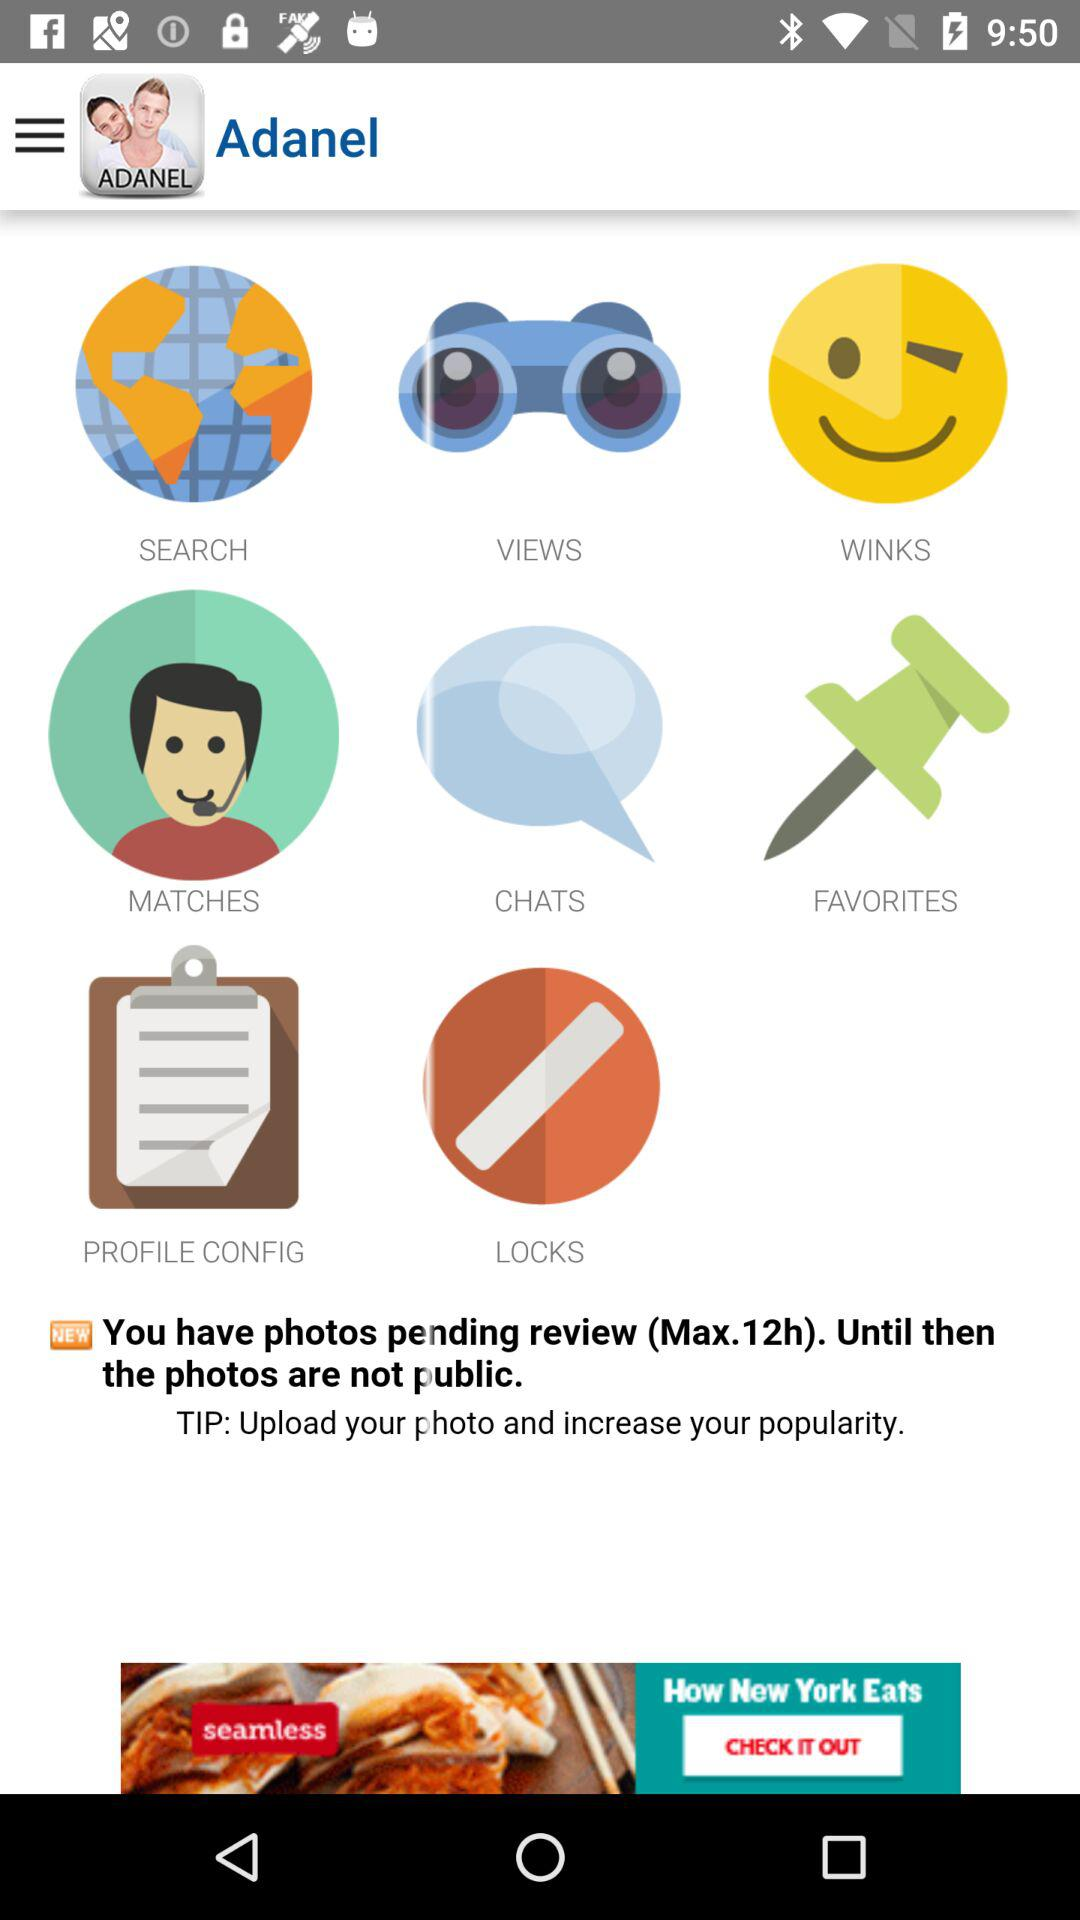What is the maximum time for review of pending photos? The maximum time is 12 hours. 